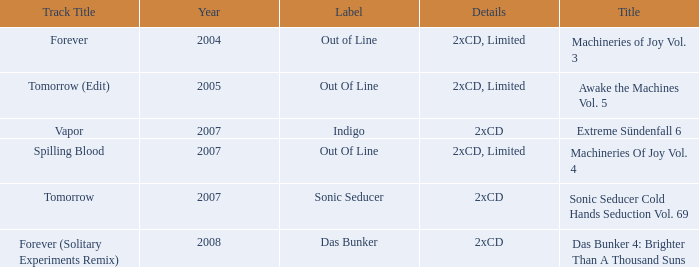Which details has the out of line label and the year of 2005? 2xCD, Limited. 